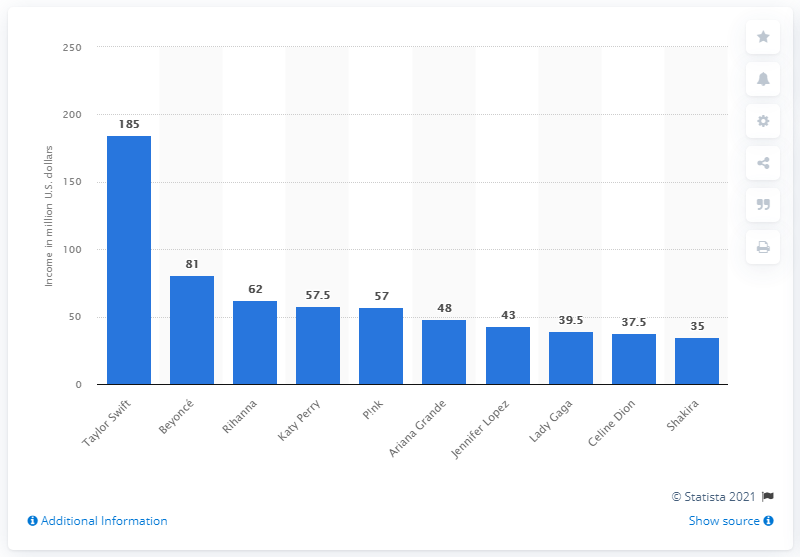Specify some key components in this picture. Taylor Swift was the highest paid female music celebrity between June 2018 and June 2019. 